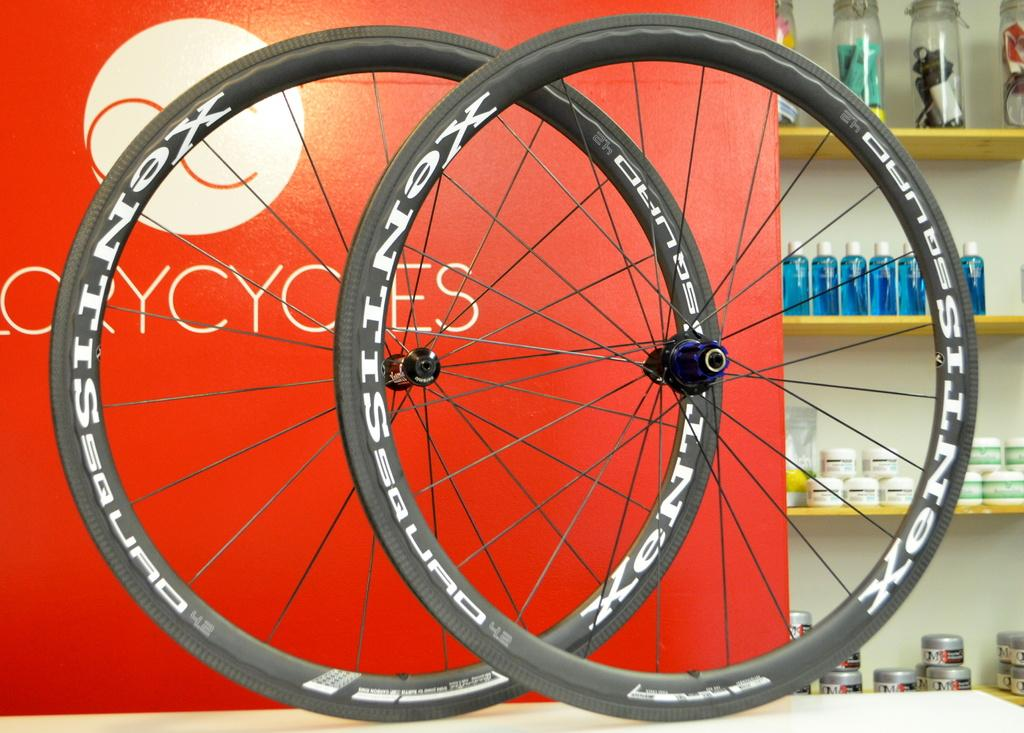What is the main subject in the center of the image? There are two cycle wheels in the center of the image. What can be seen in the background of the image? There is a poster and shelves in the background of the image. What is the purpose of the shelves in the image? Objects are placed on the shelves, suggesting they are used for storage or display. What type of flesh can be seen hanging from the cycle wheels in the image? There is no flesh present in the image; it features two cycle wheels and a background with a poster and shelves. 